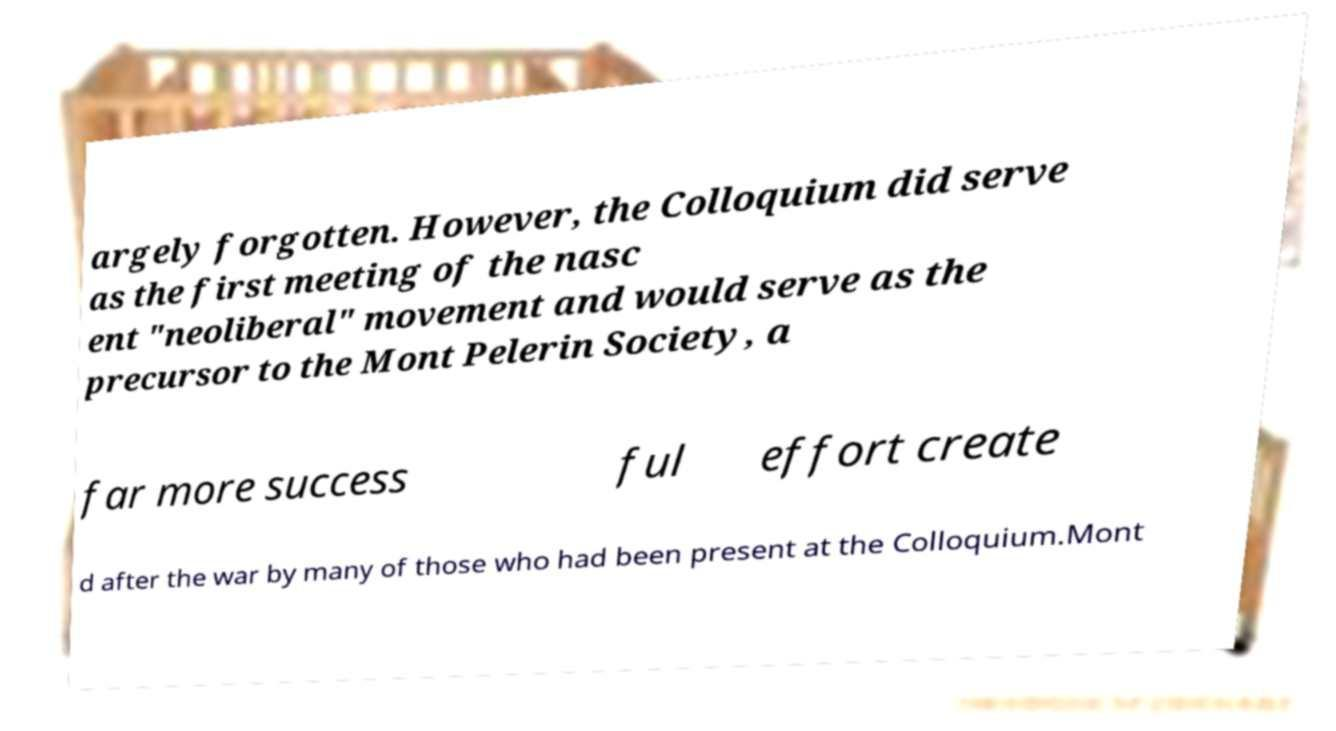I need the written content from this picture converted into text. Can you do that? argely forgotten. However, the Colloquium did serve as the first meeting of the nasc ent "neoliberal" movement and would serve as the precursor to the Mont Pelerin Society, a far more success ful effort create d after the war by many of those who had been present at the Colloquium.Mont 